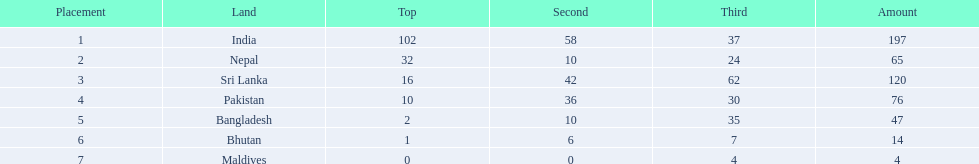Which countries won medals? India, Nepal, Sri Lanka, Pakistan, Bangladesh, Bhutan, Maldives. Which won the most? India. Which won the fewest? Maldives. 